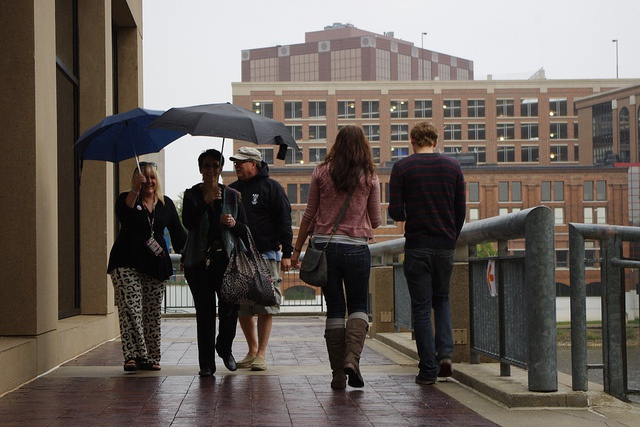Describe the objects in this image and their specific colors. I can see people in black, maroon, and gray tones, people in black, maroon, and gray tones, people in black and gray tones, people in black, gray, and maroon tones, and people in black, gray, maroon, and darkgray tones in this image. 